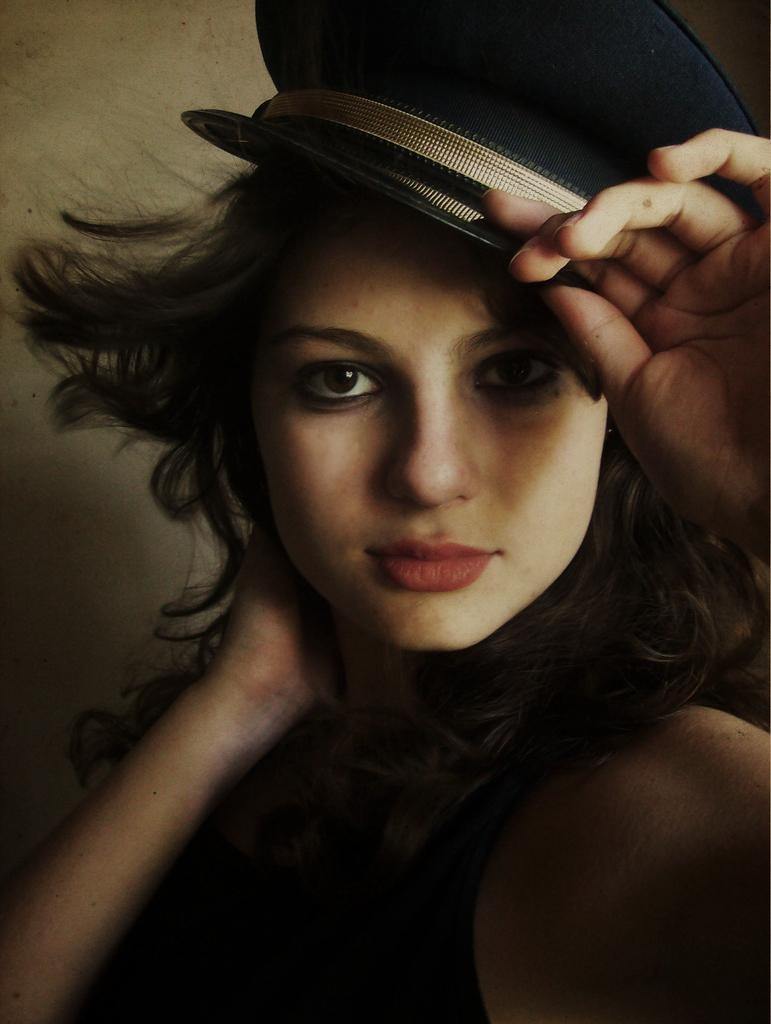Who is present in the image? There is a woman in the image. What is the woman wearing? The woman is wearing a black dress and a cap. What is the woman doing in the image? The woman is looking at something. What can be seen in the background of the image? There is a wall in the background of the image. What type of cracker is the woman holding in the image? There is no cracker present in the image. Can you see any beetles crawling on the wall in the background? There are no beetles visible in the image; only the woman and the wall are present. 